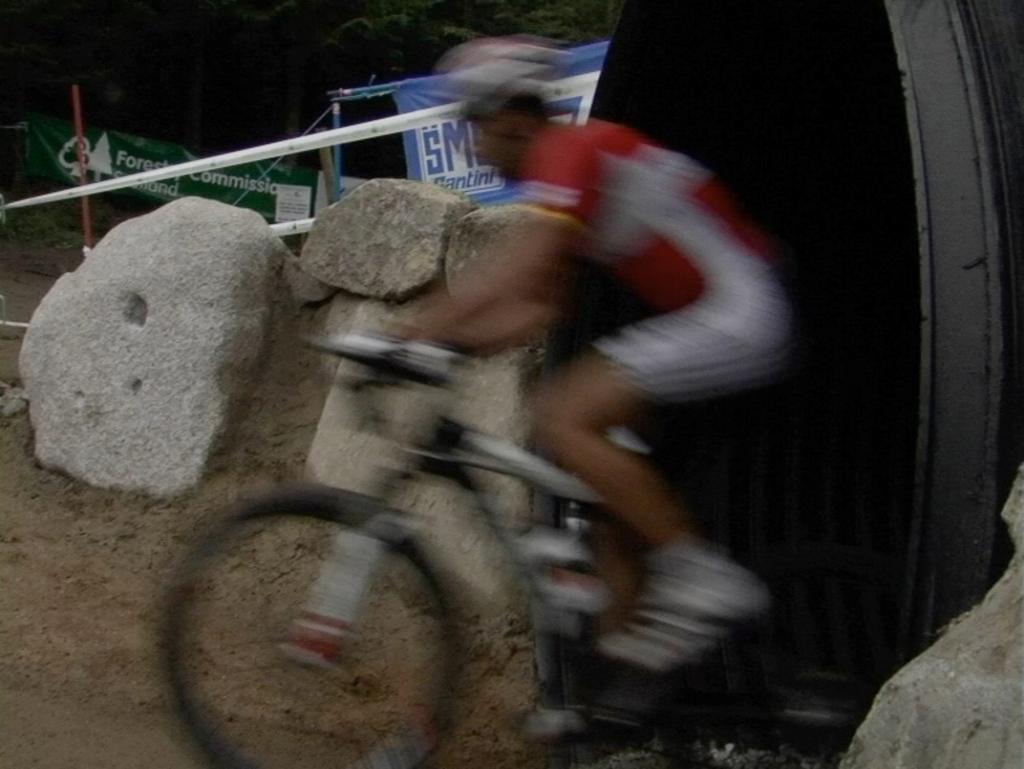Can you describe this image briefly? This is a blurred image. In this picture, man in red and white t-shirt riding bicycle. Beside him, we see rock. Beside that we see banner which is blue in color and beside that, we see trees. 